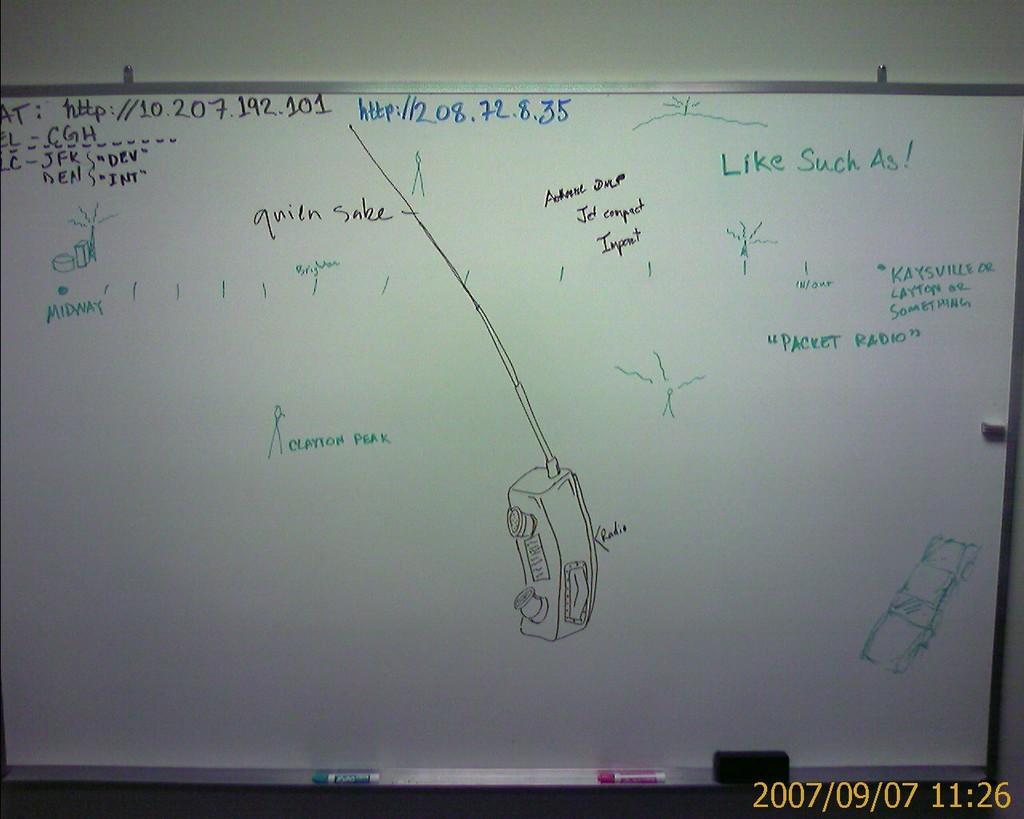Can you describe this image briefly? In this image we can see a board on a wall with some text on it. We can also see the markers. 